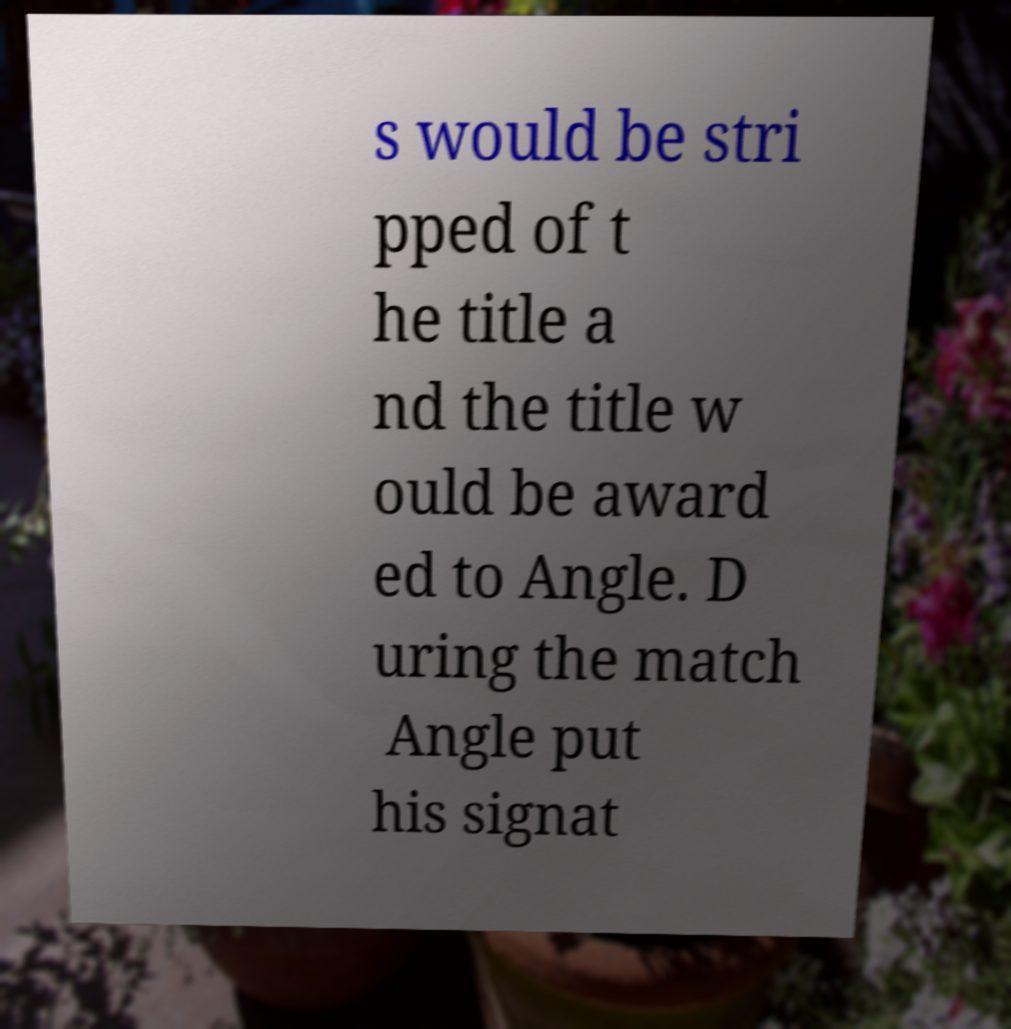Could you assist in decoding the text presented in this image and type it out clearly? s would be stri pped of t he title a nd the title w ould be award ed to Angle. D uring the match Angle put his signat 